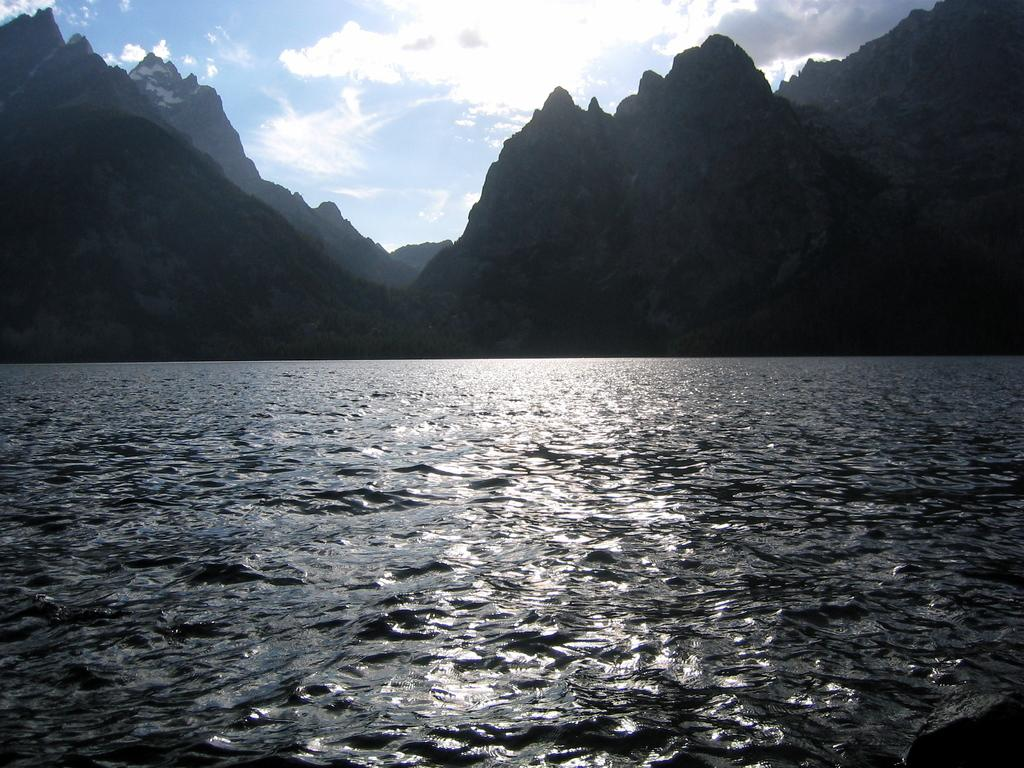What is the main element present in the image? There is water in the image. What type of geographical feature can be seen in the image? There are hills in the image. What color is the sky in the background of the image? The sky is blue in the background. What can be observed in the sky besides its color? Clouds are visible in the sky. How many quarters can be seen resting on the hill in the image? There are no quarters present in the image; it features water, hills, a blue sky, and clouds. What type of rest is the hill providing in the image? The hill is not providing any rest in the image; it is a geographical feature. 